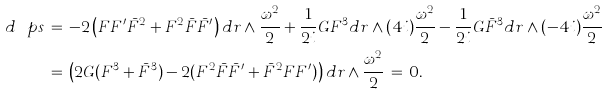Convert formula to latex. <formula><loc_0><loc_0><loc_500><loc_500>d \ p s \, & = \, - 2 \left ( F F ^ { \prime } \bar { F } ^ { 2 } + F ^ { 2 } \bar { F } \bar { F } ^ { \prime } \right ) d r \wedge \frac { \omega ^ { 2 } } { 2 } + \frac { 1 } { 2 i } G F ^ { 3 } d r \wedge ( 4 i ) \frac { \omega ^ { 2 } } { 2 } - \frac { 1 } { 2 i } G \bar { F } ^ { 3 } d r \wedge ( - 4 i ) \frac { \omega ^ { 2 } } { 2 } \\ & = \, \left ( 2 G ( F ^ { 3 } + \bar { F } ^ { 3 } ) - 2 ( F ^ { 2 } \bar { F } \bar { F } ^ { \prime } + \bar { F } ^ { 2 } F F ^ { \prime } ) \right ) d r \wedge \frac { \omega ^ { 2 } } { 2 } \, = \, 0 .</formula> 